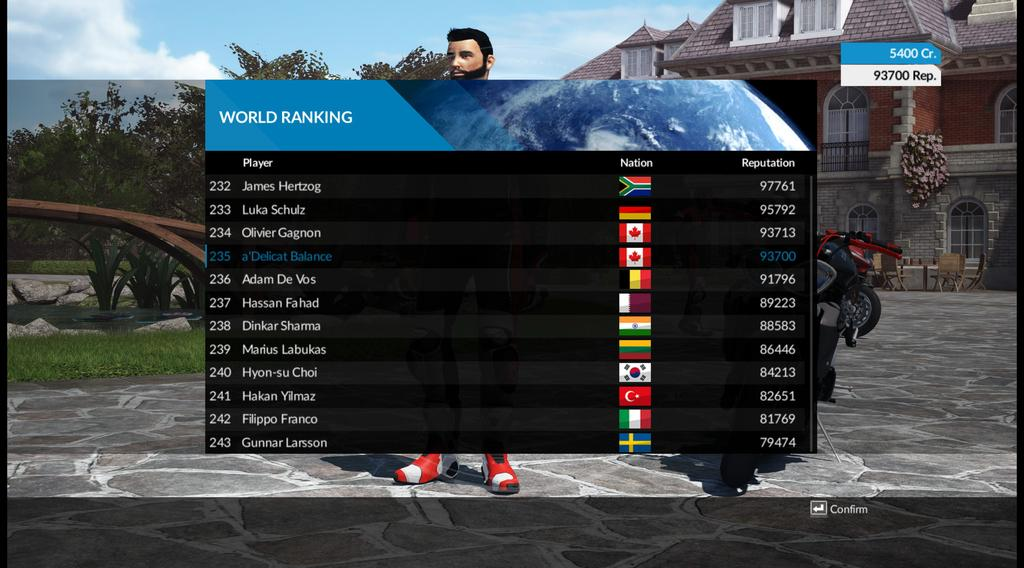<image>
Write a terse but informative summary of the picture. game screen with listing of world rankings, flags of nations and numbers for reputation 